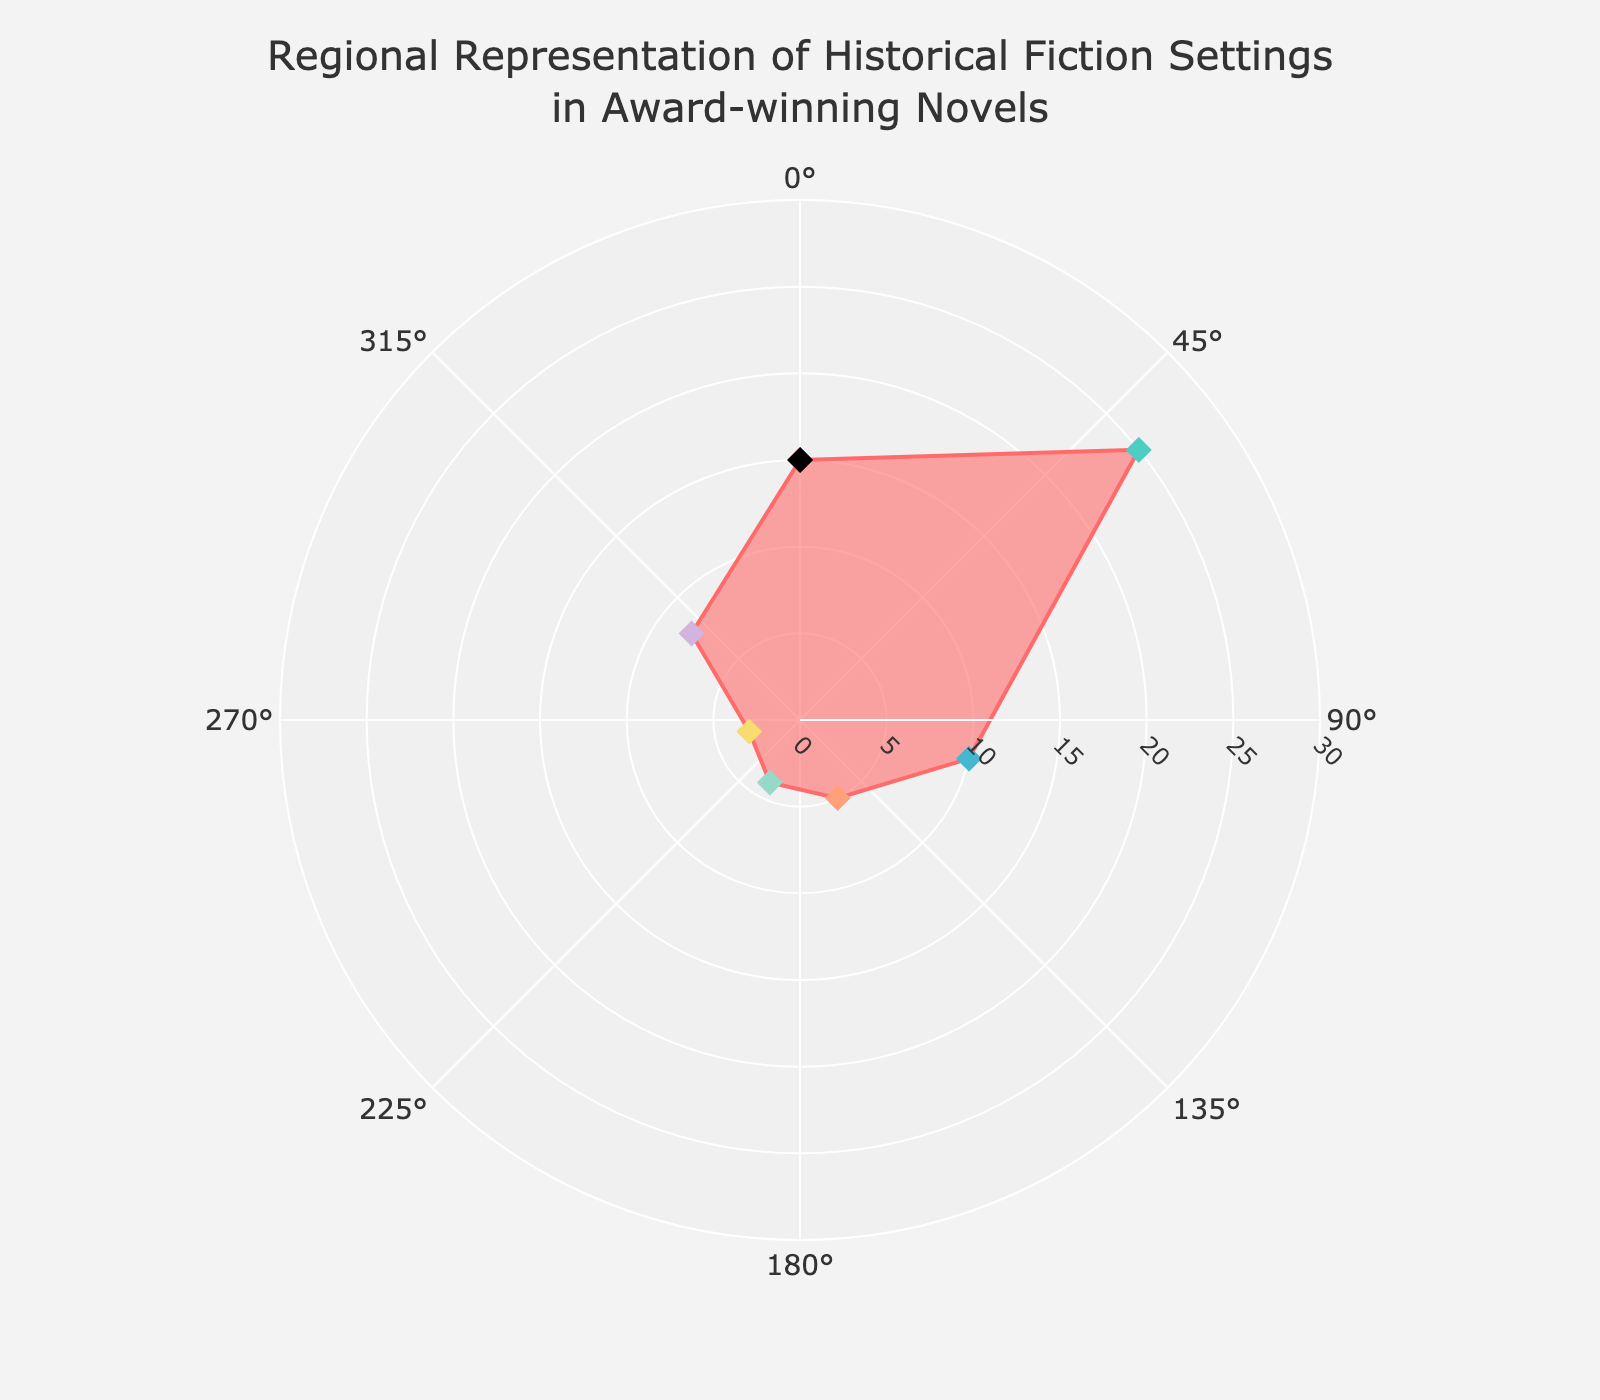What's the dominant region for historical fiction settings? The region with the highest number of novels can be identified by observing which segment extends the farthest from the center on the rose chart. Here, Europe is the longest segment.
Answer: Europe Which region has the least representation? To find the least represented region, look at the shortest segment on the chart. Oceania has the shortest segment, indicating the fewest novels.
Answer: Oceania How many regions have more than 10 novels? By counting the number of segments that extend beyond the 10 novel mark on the radial axis, we can see that two regions (North America and Europe) meet this criterion.
Answer: 2 What's the total number of novels represented in the chart? By summing the numbers of novels for each region (15 for North America, 25 for Europe, 10 for Asia, 5 for Africa, 4 for South America, 3 for Oceania, and 8 for Middle East), we get 15 + 25 + 10 + 5 + 4 + 3 + 8 = 70.
Answer: 70 How does North America's representation compare to Asia? By comparing the segments for North America and Asia, we see that North America has 15 novels, while Asia has 10 novels. North America has 5 more novels than Asia.
Answer: North America has 5 more novels than Asia Which regions have fewer novels than Africa? We compare the lengths of regions' segments to Africa's segment. Africa has 5 novels. South America (4 novels) and Oceania (3 novels) both have fewer novels than Africa.
Answer: South America and Oceania What is the combined novel count for South America and the Middle East? By adding the numbers of novels for South America (4) and the Middle East (8), we get 4 + 8 = 12.
Answer: 12 What's the average number of novels per region? To find the average, we divide the total number of novels (70) by the number of regions (7): 70 / 7 = 10.
Answer: 10 What's the range of the number of novels across the regions? To determine the range, we subtract the smallest number of novels (Oceania with 3 novels) from the largest number of novels (Europe with 25 novels): 25 - 3 = 22.
Answer: 22 What percentage of the novels are set in Europe? To find the percentage, divide the number of novels set in Europe (25) by the total number of novels (70) and multiply by 100: (25 / 70) * 100 ≈ 35.71%.
Answer: 35.71% 